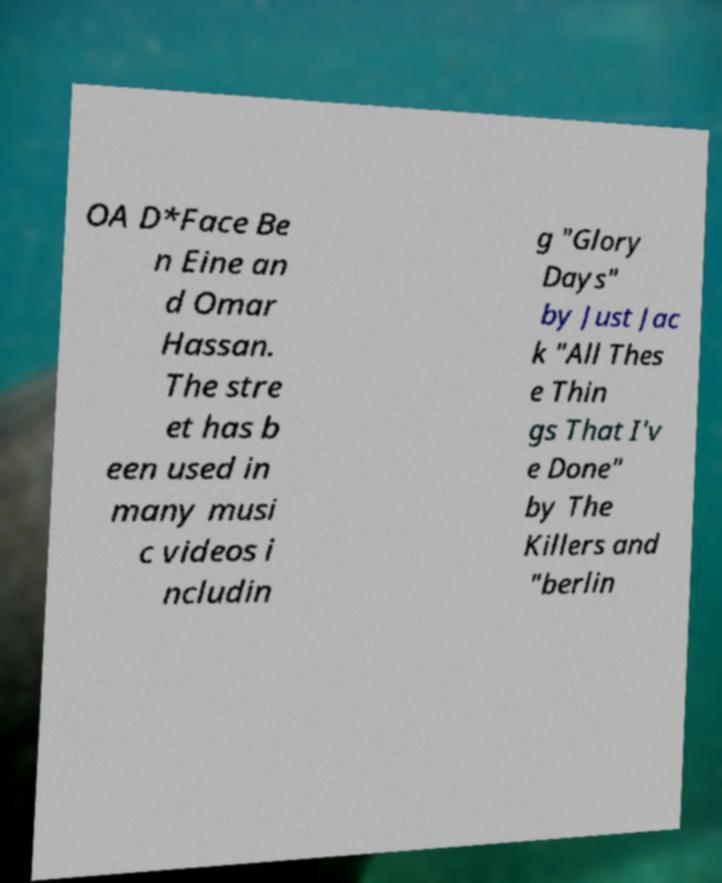Could you assist in decoding the text presented in this image and type it out clearly? OA D*Face Be n Eine an d Omar Hassan. The stre et has b een used in many musi c videos i ncludin g "Glory Days" by Just Jac k "All Thes e Thin gs That I'v e Done" by The Killers and "berlin 